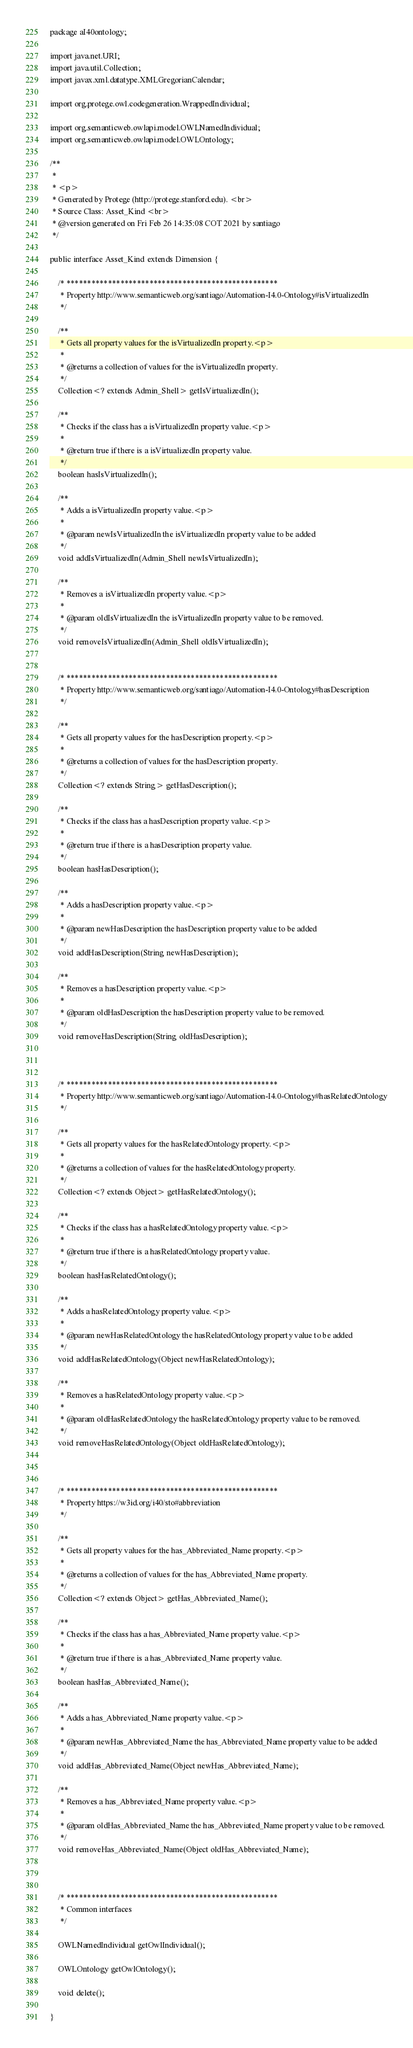<code> <loc_0><loc_0><loc_500><loc_500><_Java_>package aI40ontology;

import java.net.URI;
import java.util.Collection;
import javax.xml.datatype.XMLGregorianCalendar;

import org.protege.owl.codegeneration.WrappedIndividual;

import org.semanticweb.owlapi.model.OWLNamedIndividual;
import org.semanticweb.owlapi.model.OWLOntology;

/**
 * 
 * <p>
 * Generated by Protege (http://protege.stanford.edu). <br>
 * Source Class: Asset_Kind <br>
 * @version generated on Fri Feb 26 14:35:08 COT 2021 by santiago
 */

public interface Asset_Kind extends Dimension {

    /* ***************************************************
     * Property http://www.semanticweb.org/santiago/Automation-I4.0-Ontology#isVirtualizedIn
     */
     
    /**
     * Gets all property values for the isVirtualizedIn property.<p>
     * 
     * @returns a collection of values for the isVirtualizedIn property.
     */
    Collection<? extends Admin_Shell> getIsVirtualizedIn();

    /**
     * Checks if the class has a isVirtualizedIn property value.<p>
     * 
     * @return true if there is a isVirtualizedIn property value.
     */
    boolean hasIsVirtualizedIn();

    /**
     * Adds a isVirtualizedIn property value.<p>
     * 
     * @param newIsVirtualizedIn the isVirtualizedIn property value to be added
     */
    void addIsVirtualizedIn(Admin_Shell newIsVirtualizedIn);

    /**
     * Removes a isVirtualizedIn property value.<p>
     * 
     * @param oldIsVirtualizedIn the isVirtualizedIn property value to be removed.
     */
    void removeIsVirtualizedIn(Admin_Shell oldIsVirtualizedIn);


    /* ***************************************************
     * Property http://www.semanticweb.org/santiago/Automation-I4.0-Ontology#hasDescription
     */
     
    /**
     * Gets all property values for the hasDescription property.<p>
     * 
     * @returns a collection of values for the hasDescription property.
     */
    Collection<? extends String> getHasDescription();

    /**
     * Checks if the class has a hasDescription property value.<p>
     * 
     * @return true if there is a hasDescription property value.
     */
    boolean hasHasDescription();

    /**
     * Adds a hasDescription property value.<p>
     * 
     * @param newHasDescription the hasDescription property value to be added
     */
    void addHasDescription(String newHasDescription);

    /**
     * Removes a hasDescription property value.<p>
     * 
     * @param oldHasDescription the hasDescription property value to be removed.
     */
    void removeHasDescription(String oldHasDescription);



    /* ***************************************************
     * Property http://www.semanticweb.org/santiago/Automation-I4.0-Ontology#hasRelatedOntology
     */
     
    /**
     * Gets all property values for the hasRelatedOntology property.<p>
     * 
     * @returns a collection of values for the hasRelatedOntology property.
     */
    Collection<? extends Object> getHasRelatedOntology();

    /**
     * Checks if the class has a hasRelatedOntology property value.<p>
     * 
     * @return true if there is a hasRelatedOntology property value.
     */
    boolean hasHasRelatedOntology();

    /**
     * Adds a hasRelatedOntology property value.<p>
     * 
     * @param newHasRelatedOntology the hasRelatedOntology property value to be added
     */
    void addHasRelatedOntology(Object newHasRelatedOntology);

    /**
     * Removes a hasRelatedOntology property value.<p>
     * 
     * @param oldHasRelatedOntology the hasRelatedOntology property value to be removed.
     */
    void removeHasRelatedOntology(Object oldHasRelatedOntology);



    /* ***************************************************
     * Property https://w3id.org/i40/sto#abbreviation
     */
     
    /**
     * Gets all property values for the has_Abbreviated_Name property.<p>
     * 
     * @returns a collection of values for the has_Abbreviated_Name property.
     */
    Collection<? extends Object> getHas_Abbreviated_Name();

    /**
     * Checks if the class has a has_Abbreviated_Name property value.<p>
     * 
     * @return true if there is a has_Abbreviated_Name property value.
     */
    boolean hasHas_Abbreviated_Name();

    /**
     * Adds a has_Abbreviated_Name property value.<p>
     * 
     * @param newHas_Abbreviated_Name the has_Abbreviated_Name property value to be added
     */
    void addHas_Abbreviated_Name(Object newHas_Abbreviated_Name);

    /**
     * Removes a has_Abbreviated_Name property value.<p>
     * 
     * @param oldHas_Abbreviated_Name the has_Abbreviated_Name property value to be removed.
     */
    void removeHas_Abbreviated_Name(Object oldHas_Abbreviated_Name);



    /* ***************************************************
     * Common interfaces
     */

    OWLNamedIndividual getOwlIndividual();

    OWLOntology getOwlOntology();

    void delete();

}
</code> 